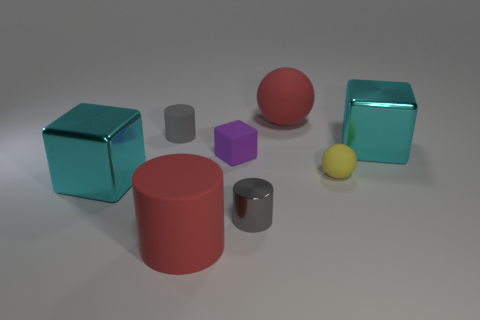There is a red rubber thing that is in front of the rubber block; does it have the same size as the small yellow sphere?
Your answer should be compact. No. Does the big rubber cylinder have the same color as the big ball?
Your answer should be compact. Yes. What is the size of the thing that is both to the left of the large matte cylinder and in front of the small matte cylinder?
Your answer should be very brief. Large. What is the color of the other large matte object that is the same shape as the yellow thing?
Give a very brief answer. Red. Is there a rubber ball behind the big cyan metallic block behind the small yellow rubber sphere?
Make the answer very short. Yes. What is the size of the matte cube?
Make the answer very short. Small. There is a matte thing that is both in front of the gray rubber object and right of the tiny gray metal thing; what shape is it?
Make the answer very short. Sphere. What number of brown things are either tiny metal cylinders or tiny cylinders?
Offer a terse response. 0. There is a red matte thing in front of the big red rubber ball; does it have the same size as the cylinder right of the tiny purple object?
Give a very brief answer. No. What number of things are either tiny cyan rubber cylinders or gray cylinders?
Provide a succinct answer. 2. 